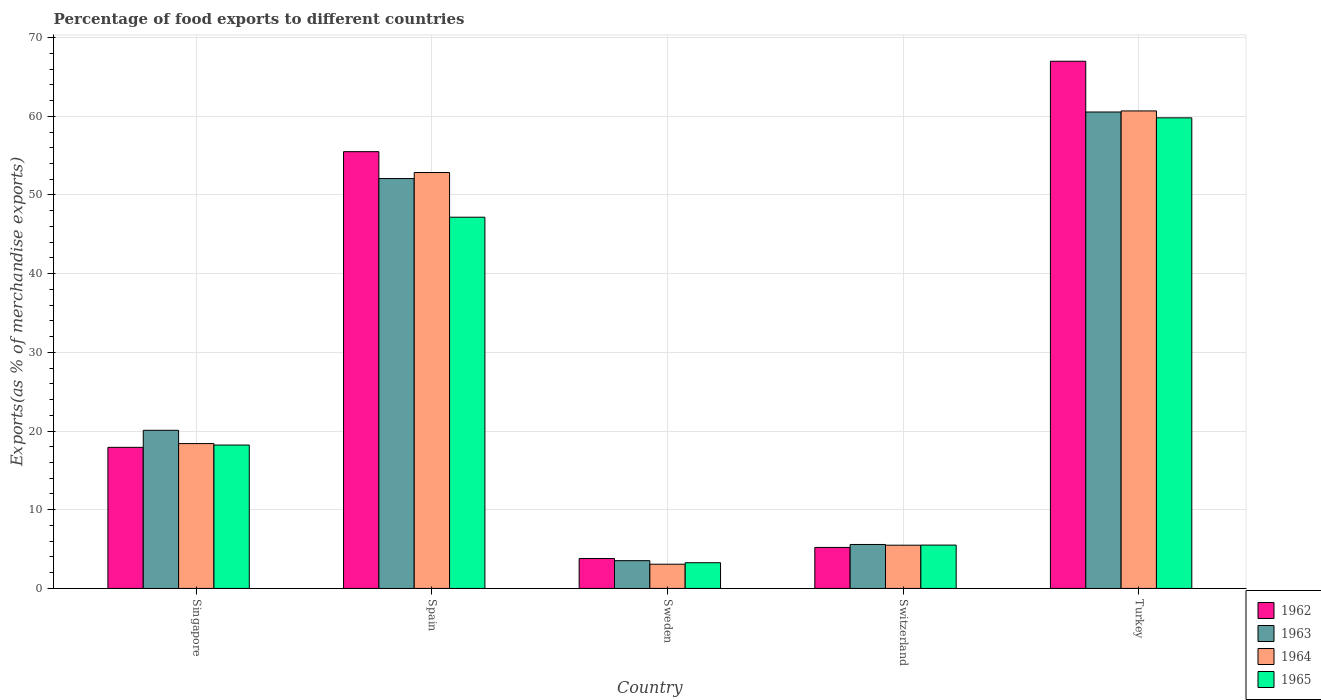How many different coloured bars are there?
Your answer should be compact. 4. Are the number of bars on each tick of the X-axis equal?
Provide a short and direct response. Yes. How many bars are there on the 1st tick from the right?
Give a very brief answer. 4. What is the label of the 4th group of bars from the left?
Give a very brief answer. Switzerland. In how many cases, is the number of bars for a given country not equal to the number of legend labels?
Your answer should be very brief. 0. What is the percentage of exports to different countries in 1965 in Singapore?
Provide a succinct answer. 18.22. Across all countries, what is the maximum percentage of exports to different countries in 1965?
Provide a short and direct response. 59.8. Across all countries, what is the minimum percentage of exports to different countries in 1962?
Provide a short and direct response. 3.8. What is the total percentage of exports to different countries in 1962 in the graph?
Ensure brevity in your answer.  149.44. What is the difference between the percentage of exports to different countries in 1963 in Spain and that in Switzerland?
Your answer should be very brief. 46.5. What is the difference between the percentage of exports to different countries in 1965 in Switzerland and the percentage of exports to different countries in 1962 in Spain?
Give a very brief answer. -49.99. What is the average percentage of exports to different countries in 1965 per country?
Make the answer very short. 26.79. What is the difference between the percentage of exports to different countries of/in 1963 and percentage of exports to different countries of/in 1962 in Singapore?
Ensure brevity in your answer.  2.16. What is the ratio of the percentage of exports to different countries in 1962 in Spain to that in Switzerland?
Your answer should be compact. 10.65. Is the percentage of exports to different countries in 1963 in Spain less than that in Switzerland?
Offer a terse response. No. Is the difference between the percentage of exports to different countries in 1963 in Spain and Sweden greater than the difference between the percentage of exports to different countries in 1962 in Spain and Sweden?
Provide a short and direct response. No. What is the difference between the highest and the second highest percentage of exports to different countries in 1963?
Offer a terse response. 40.45. What is the difference between the highest and the lowest percentage of exports to different countries in 1962?
Provide a short and direct response. 63.19. Is the sum of the percentage of exports to different countries in 1964 in Sweden and Switzerland greater than the maximum percentage of exports to different countries in 1963 across all countries?
Keep it short and to the point. No. What does the 2nd bar from the right in Switzerland represents?
Provide a short and direct response. 1964. Are all the bars in the graph horizontal?
Give a very brief answer. No. How many countries are there in the graph?
Give a very brief answer. 5. Are the values on the major ticks of Y-axis written in scientific E-notation?
Keep it short and to the point. No. Does the graph contain any zero values?
Offer a terse response. No. Does the graph contain grids?
Give a very brief answer. Yes. Where does the legend appear in the graph?
Give a very brief answer. Bottom right. How many legend labels are there?
Make the answer very short. 4. What is the title of the graph?
Make the answer very short. Percentage of food exports to different countries. What is the label or title of the Y-axis?
Keep it short and to the point. Exports(as % of merchandise exports). What is the Exports(as % of merchandise exports) in 1962 in Singapore?
Provide a short and direct response. 17.93. What is the Exports(as % of merchandise exports) in 1963 in Singapore?
Ensure brevity in your answer.  20.09. What is the Exports(as % of merchandise exports) of 1964 in Singapore?
Ensure brevity in your answer.  18.41. What is the Exports(as % of merchandise exports) of 1965 in Singapore?
Keep it short and to the point. 18.22. What is the Exports(as % of merchandise exports) in 1962 in Spain?
Ensure brevity in your answer.  55.5. What is the Exports(as % of merchandise exports) of 1963 in Spain?
Provide a short and direct response. 52.09. What is the Exports(as % of merchandise exports) of 1964 in Spain?
Give a very brief answer. 52.85. What is the Exports(as % of merchandise exports) in 1965 in Spain?
Your answer should be compact. 47.17. What is the Exports(as % of merchandise exports) of 1962 in Sweden?
Ensure brevity in your answer.  3.8. What is the Exports(as % of merchandise exports) in 1963 in Sweden?
Provide a short and direct response. 3.53. What is the Exports(as % of merchandise exports) in 1964 in Sweden?
Provide a succinct answer. 3.08. What is the Exports(as % of merchandise exports) of 1965 in Sweden?
Keep it short and to the point. 3.27. What is the Exports(as % of merchandise exports) of 1962 in Switzerland?
Make the answer very short. 5.21. What is the Exports(as % of merchandise exports) in 1963 in Switzerland?
Provide a succinct answer. 5.59. What is the Exports(as % of merchandise exports) in 1964 in Switzerland?
Make the answer very short. 5.49. What is the Exports(as % of merchandise exports) in 1965 in Switzerland?
Provide a succinct answer. 5.51. What is the Exports(as % of merchandise exports) in 1962 in Turkey?
Offer a terse response. 66.99. What is the Exports(as % of merchandise exports) of 1963 in Turkey?
Your response must be concise. 60.54. What is the Exports(as % of merchandise exports) in 1964 in Turkey?
Provide a succinct answer. 60.68. What is the Exports(as % of merchandise exports) in 1965 in Turkey?
Give a very brief answer. 59.8. Across all countries, what is the maximum Exports(as % of merchandise exports) of 1962?
Your response must be concise. 66.99. Across all countries, what is the maximum Exports(as % of merchandise exports) of 1963?
Keep it short and to the point. 60.54. Across all countries, what is the maximum Exports(as % of merchandise exports) of 1964?
Your answer should be compact. 60.68. Across all countries, what is the maximum Exports(as % of merchandise exports) of 1965?
Provide a succinct answer. 59.8. Across all countries, what is the minimum Exports(as % of merchandise exports) of 1962?
Keep it short and to the point. 3.8. Across all countries, what is the minimum Exports(as % of merchandise exports) in 1963?
Offer a very short reply. 3.53. Across all countries, what is the minimum Exports(as % of merchandise exports) of 1964?
Give a very brief answer. 3.08. Across all countries, what is the minimum Exports(as % of merchandise exports) in 1965?
Provide a short and direct response. 3.27. What is the total Exports(as % of merchandise exports) in 1962 in the graph?
Make the answer very short. 149.44. What is the total Exports(as % of merchandise exports) in 1963 in the graph?
Provide a succinct answer. 141.83. What is the total Exports(as % of merchandise exports) in 1964 in the graph?
Offer a very short reply. 140.51. What is the total Exports(as % of merchandise exports) of 1965 in the graph?
Provide a succinct answer. 133.97. What is the difference between the Exports(as % of merchandise exports) of 1962 in Singapore and that in Spain?
Your response must be concise. -37.57. What is the difference between the Exports(as % of merchandise exports) in 1963 in Singapore and that in Spain?
Make the answer very short. -31.99. What is the difference between the Exports(as % of merchandise exports) in 1964 in Singapore and that in Spain?
Keep it short and to the point. -34.45. What is the difference between the Exports(as % of merchandise exports) in 1965 in Singapore and that in Spain?
Your answer should be very brief. -28.95. What is the difference between the Exports(as % of merchandise exports) of 1962 in Singapore and that in Sweden?
Keep it short and to the point. 14.13. What is the difference between the Exports(as % of merchandise exports) in 1963 in Singapore and that in Sweden?
Your answer should be compact. 16.56. What is the difference between the Exports(as % of merchandise exports) of 1964 in Singapore and that in Sweden?
Offer a very short reply. 15.33. What is the difference between the Exports(as % of merchandise exports) in 1965 in Singapore and that in Sweden?
Your response must be concise. 14.95. What is the difference between the Exports(as % of merchandise exports) in 1962 in Singapore and that in Switzerland?
Keep it short and to the point. 12.72. What is the difference between the Exports(as % of merchandise exports) in 1963 in Singapore and that in Switzerland?
Make the answer very short. 14.51. What is the difference between the Exports(as % of merchandise exports) in 1964 in Singapore and that in Switzerland?
Ensure brevity in your answer.  12.91. What is the difference between the Exports(as % of merchandise exports) of 1965 in Singapore and that in Switzerland?
Ensure brevity in your answer.  12.71. What is the difference between the Exports(as % of merchandise exports) of 1962 in Singapore and that in Turkey?
Provide a short and direct response. -49.06. What is the difference between the Exports(as % of merchandise exports) of 1963 in Singapore and that in Turkey?
Your answer should be compact. -40.45. What is the difference between the Exports(as % of merchandise exports) in 1964 in Singapore and that in Turkey?
Your answer should be very brief. -42.27. What is the difference between the Exports(as % of merchandise exports) in 1965 in Singapore and that in Turkey?
Offer a terse response. -41.58. What is the difference between the Exports(as % of merchandise exports) of 1962 in Spain and that in Sweden?
Provide a succinct answer. 51.7. What is the difference between the Exports(as % of merchandise exports) in 1963 in Spain and that in Sweden?
Offer a very short reply. 48.56. What is the difference between the Exports(as % of merchandise exports) of 1964 in Spain and that in Sweden?
Ensure brevity in your answer.  49.77. What is the difference between the Exports(as % of merchandise exports) in 1965 in Spain and that in Sweden?
Give a very brief answer. 43.9. What is the difference between the Exports(as % of merchandise exports) in 1962 in Spain and that in Switzerland?
Offer a very short reply. 50.29. What is the difference between the Exports(as % of merchandise exports) in 1963 in Spain and that in Switzerland?
Ensure brevity in your answer.  46.5. What is the difference between the Exports(as % of merchandise exports) of 1964 in Spain and that in Switzerland?
Offer a terse response. 47.36. What is the difference between the Exports(as % of merchandise exports) in 1965 in Spain and that in Switzerland?
Keep it short and to the point. 41.67. What is the difference between the Exports(as % of merchandise exports) in 1962 in Spain and that in Turkey?
Your response must be concise. -11.49. What is the difference between the Exports(as % of merchandise exports) in 1963 in Spain and that in Turkey?
Offer a very short reply. -8.46. What is the difference between the Exports(as % of merchandise exports) of 1964 in Spain and that in Turkey?
Provide a short and direct response. -7.83. What is the difference between the Exports(as % of merchandise exports) in 1965 in Spain and that in Turkey?
Your response must be concise. -12.63. What is the difference between the Exports(as % of merchandise exports) in 1962 in Sweden and that in Switzerland?
Provide a short and direct response. -1.4. What is the difference between the Exports(as % of merchandise exports) of 1963 in Sweden and that in Switzerland?
Give a very brief answer. -2.06. What is the difference between the Exports(as % of merchandise exports) in 1964 in Sweden and that in Switzerland?
Ensure brevity in your answer.  -2.41. What is the difference between the Exports(as % of merchandise exports) in 1965 in Sweden and that in Switzerland?
Offer a terse response. -2.24. What is the difference between the Exports(as % of merchandise exports) in 1962 in Sweden and that in Turkey?
Your response must be concise. -63.19. What is the difference between the Exports(as % of merchandise exports) of 1963 in Sweden and that in Turkey?
Your response must be concise. -57.01. What is the difference between the Exports(as % of merchandise exports) of 1964 in Sweden and that in Turkey?
Provide a short and direct response. -57.6. What is the difference between the Exports(as % of merchandise exports) of 1965 in Sweden and that in Turkey?
Provide a succinct answer. -56.53. What is the difference between the Exports(as % of merchandise exports) in 1962 in Switzerland and that in Turkey?
Ensure brevity in your answer.  -61.78. What is the difference between the Exports(as % of merchandise exports) of 1963 in Switzerland and that in Turkey?
Offer a terse response. -54.96. What is the difference between the Exports(as % of merchandise exports) in 1964 in Switzerland and that in Turkey?
Keep it short and to the point. -55.18. What is the difference between the Exports(as % of merchandise exports) of 1965 in Switzerland and that in Turkey?
Give a very brief answer. -54.29. What is the difference between the Exports(as % of merchandise exports) of 1962 in Singapore and the Exports(as % of merchandise exports) of 1963 in Spain?
Keep it short and to the point. -34.16. What is the difference between the Exports(as % of merchandise exports) of 1962 in Singapore and the Exports(as % of merchandise exports) of 1964 in Spain?
Offer a very short reply. -34.92. What is the difference between the Exports(as % of merchandise exports) of 1962 in Singapore and the Exports(as % of merchandise exports) of 1965 in Spain?
Make the answer very short. -29.24. What is the difference between the Exports(as % of merchandise exports) in 1963 in Singapore and the Exports(as % of merchandise exports) in 1964 in Spain?
Your response must be concise. -32.76. What is the difference between the Exports(as % of merchandise exports) in 1963 in Singapore and the Exports(as % of merchandise exports) in 1965 in Spain?
Your answer should be compact. -27.08. What is the difference between the Exports(as % of merchandise exports) in 1964 in Singapore and the Exports(as % of merchandise exports) in 1965 in Spain?
Keep it short and to the point. -28.77. What is the difference between the Exports(as % of merchandise exports) of 1962 in Singapore and the Exports(as % of merchandise exports) of 1963 in Sweden?
Offer a very short reply. 14.4. What is the difference between the Exports(as % of merchandise exports) in 1962 in Singapore and the Exports(as % of merchandise exports) in 1964 in Sweden?
Give a very brief answer. 14.85. What is the difference between the Exports(as % of merchandise exports) of 1962 in Singapore and the Exports(as % of merchandise exports) of 1965 in Sweden?
Give a very brief answer. 14.66. What is the difference between the Exports(as % of merchandise exports) of 1963 in Singapore and the Exports(as % of merchandise exports) of 1964 in Sweden?
Ensure brevity in your answer.  17.01. What is the difference between the Exports(as % of merchandise exports) of 1963 in Singapore and the Exports(as % of merchandise exports) of 1965 in Sweden?
Make the answer very short. 16.83. What is the difference between the Exports(as % of merchandise exports) in 1964 in Singapore and the Exports(as % of merchandise exports) in 1965 in Sweden?
Provide a succinct answer. 15.14. What is the difference between the Exports(as % of merchandise exports) of 1962 in Singapore and the Exports(as % of merchandise exports) of 1963 in Switzerland?
Keep it short and to the point. 12.34. What is the difference between the Exports(as % of merchandise exports) in 1962 in Singapore and the Exports(as % of merchandise exports) in 1964 in Switzerland?
Your answer should be compact. 12.44. What is the difference between the Exports(as % of merchandise exports) of 1962 in Singapore and the Exports(as % of merchandise exports) of 1965 in Switzerland?
Make the answer very short. 12.42. What is the difference between the Exports(as % of merchandise exports) of 1963 in Singapore and the Exports(as % of merchandise exports) of 1964 in Switzerland?
Offer a very short reply. 14.6. What is the difference between the Exports(as % of merchandise exports) in 1963 in Singapore and the Exports(as % of merchandise exports) in 1965 in Switzerland?
Your response must be concise. 14.59. What is the difference between the Exports(as % of merchandise exports) in 1964 in Singapore and the Exports(as % of merchandise exports) in 1965 in Switzerland?
Ensure brevity in your answer.  12.9. What is the difference between the Exports(as % of merchandise exports) in 1962 in Singapore and the Exports(as % of merchandise exports) in 1963 in Turkey?
Your answer should be compact. -42.61. What is the difference between the Exports(as % of merchandise exports) in 1962 in Singapore and the Exports(as % of merchandise exports) in 1964 in Turkey?
Your answer should be compact. -42.75. What is the difference between the Exports(as % of merchandise exports) in 1962 in Singapore and the Exports(as % of merchandise exports) in 1965 in Turkey?
Provide a succinct answer. -41.87. What is the difference between the Exports(as % of merchandise exports) in 1963 in Singapore and the Exports(as % of merchandise exports) in 1964 in Turkey?
Offer a terse response. -40.59. What is the difference between the Exports(as % of merchandise exports) in 1963 in Singapore and the Exports(as % of merchandise exports) in 1965 in Turkey?
Offer a very short reply. -39.71. What is the difference between the Exports(as % of merchandise exports) in 1964 in Singapore and the Exports(as % of merchandise exports) in 1965 in Turkey?
Give a very brief answer. -41.39. What is the difference between the Exports(as % of merchandise exports) in 1962 in Spain and the Exports(as % of merchandise exports) in 1963 in Sweden?
Offer a very short reply. 51.97. What is the difference between the Exports(as % of merchandise exports) in 1962 in Spain and the Exports(as % of merchandise exports) in 1964 in Sweden?
Keep it short and to the point. 52.42. What is the difference between the Exports(as % of merchandise exports) in 1962 in Spain and the Exports(as % of merchandise exports) in 1965 in Sweden?
Your response must be concise. 52.23. What is the difference between the Exports(as % of merchandise exports) of 1963 in Spain and the Exports(as % of merchandise exports) of 1964 in Sweden?
Make the answer very short. 49.01. What is the difference between the Exports(as % of merchandise exports) of 1963 in Spain and the Exports(as % of merchandise exports) of 1965 in Sweden?
Your response must be concise. 48.82. What is the difference between the Exports(as % of merchandise exports) in 1964 in Spain and the Exports(as % of merchandise exports) in 1965 in Sweden?
Give a very brief answer. 49.58. What is the difference between the Exports(as % of merchandise exports) of 1962 in Spain and the Exports(as % of merchandise exports) of 1963 in Switzerland?
Ensure brevity in your answer.  49.92. What is the difference between the Exports(as % of merchandise exports) of 1962 in Spain and the Exports(as % of merchandise exports) of 1964 in Switzerland?
Provide a short and direct response. 50.01. What is the difference between the Exports(as % of merchandise exports) of 1962 in Spain and the Exports(as % of merchandise exports) of 1965 in Switzerland?
Give a very brief answer. 49.99. What is the difference between the Exports(as % of merchandise exports) in 1963 in Spain and the Exports(as % of merchandise exports) in 1964 in Switzerland?
Your answer should be very brief. 46.59. What is the difference between the Exports(as % of merchandise exports) in 1963 in Spain and the Exports(as % of merchandise exports) in 1965 in Switzerland?
Your response must be concise. 46.58. What is the difference between the Exports(as % of merchandise exports) in 1964 in Spain and the Exports(as % of merchandise exports) in 1965 in Switzerland?
Your response must be concise. 47.35. What is the difference between the Exports(as % of merchandise exports) in 1962 in Spain and the Exports(as % of merchandise exports) in 1963 in Turkey?
Offer a terse response. -5.04. What is the difference between the Exports(as % of merchandise exports) in 1962 in Spain and the Exports(as % of merchandise exports) in 1964 in Turkey?
Offer a very short reply. -5.18. What is the difference between the Exports(as % of merchandise exports) of 1962 in Spain and the Exports(as % of merchandise exports) of 1965 in Turkey?
Your response must be concise. -4.3. What is the difference between the Exports(as % of merchandise exports) of 1963 in Spain and the Exports(as % of merchandise exports) of 1964 in Turkey?
Your answer should be very brief. -8.59. What is the difference between the Exports(as % of merchandise exports) in 1963 in Spain and the Exports(as % of merchandise exports) in 1965 in Turkey?
Provide a succinct answer. -7.71. What is the difference between the Exports(as % of merchandise exports) in 1964 in Spain and the Exports(as % of merchandise exports) in 1965 in Turkey?
Give a very brief answer. -6.95. What is the difference between the Exports(as % of merchandise exports) of 1962 in Sweden and the Exports(as % of merchandise exports) of 1963 in Switzerland?
Ensure brevity in your answer.  -1.78. What is the difference between the Exports(as % of merchandise exports) in 1962 in Sweden and the Exports(as % of merchandise exports) in 1964 in Switzerland?
Offer a very short reply. -1.69. What is the difference between the Exports(as % of merchandise exports) in 1962 in Sweden and the Exports(as % of merchandise exports) in 1965 in Switzerland?
Your answer should be very brief. -1.7. What is the difference between the Exports(as % of merchandise exports) in 1963 in Sweden and the Exports(as % of merchandise exports) in 1964 in Switzerland?
Give a very brief answer. -1.96. What is the difference between the Exports(as % of merchandise exports) of 1963 in Sweden and the Exports(as % of merchandise exports) of 1965 in Switzerland?
Offer a very short reply. -1.98. What is the difference between the Exports(as % of merchandise exports) in 1964 in Sweden and the Exports(as % of merchandise exports) in 1965 in Switzerland?
Offer a very short reply. -2.43. What is the difference between the Exports(as % of merchandise exports) of 1962 in Sweden and the Exports(as % of merchandise exports) of 1963 in Turkey?
Your answer should be compact. -56.74. What is the difference between the Exports(as % of merchandise exports) in 1962 in Sweden and the Exports(as % of merchandise exports) in 1964 in Turkey?
Offer a very short reply. -56.87. What is the difference between the Exports(as % of merchandise exports) of 1962 in Sweden and the Exports(as % of merchandise exports) of 1965 in Turkey?
Give a very brief answer. -55.99. What is the difference between the Exports(as % of merchandise exports) in 1963 in Sweden and the Exports(as % of merchandise exports) in 1964 in Turkey?
Provide a succinct answer. -57.15. What is the difference between the Exports(as % of merchandise exports) in 1963 in Sweden and the Exports(as % of merchandise exports) in 1965 in Turkey?
Offer a very short reply. -56.27. What is the difference between the Exports(as % of merchandise exports) of 1964 in Sweden and the Exports(as % of merchandise exports) of 1965 in Turkey?
Provide a succinct answer. -56.72. What is the difference between the Exports(as % of merchandise exports) of 1962 in Switzerland and the Exports(as % of merchandise exports) of 1963 in Turkey?
Offer a very short reply. -55.33. What is the difference between the Exports(as % of merchandise exports) in 1962 in Switzerland and the Exports(as % of merchandise exports) in 1964 in Turkey?
Make the answer very short. -55.47. What is the difference between the Exports(as % of merchandise exports) in 1962 in Switzerland and the Exports(as % of merchandise exports) in 1965 in Turkey?
Ensure brevity in your answer.  -54.59. What is the difference between the Exports(as % of merchandise exports) of 1963 in Switzerland and the Exports(as % of merchandise exports) of 1964 in Turkey?
Give a very brief answer. -55.09. What is the difference between the Exports(as % of merchandise exports) in 1963 in Switzerland and the Exports(as % of merchandise exports) in 1965 in Turkey?
Give a very brief answer. -54.21. What is the difference between the Exports(as % of merchandise exports) of 1964 in Switzerland and the Exports(as % of merchandise exports) of 1965 in Turkey?
Keep it short and to the point. -54.31. What is the average Exports(as % of merchandise exports) in 1962 per country?
Provide a short and direct response. 29.89. What is the average Exports(as % of merchandise exports) in 1963 per country?
Provide a short and direct response. 28.37. What is the average Exports(as % of merchandise exports) of 1964 per country?
Your answer should be compact. 28.1. What is the average Exports(as % of merchandise exports) in 1965 per country?
Your answer should be compact. 26.79. What is the difference between the Exports(as % of merchandise exports) in 1962 and Exports(as % of merchandise exports) in 1963 in Singapore?
Make the answer very short. -2.16. What is the difference between the Exports(as % of merchandise exports) of 1962 and Exports(as % of merchandise exports) of 1964 in Singapore?
Give a very brief answer. -0.48. What is the difference between the Exports(as % of merchandise exports) in 1962 and Exports(as % of merchandise exports) in 1965 in Singapore?
Keep it short and to the point. -0.29. What is the difference between the Exports(as % of merchandise exports) of 1963 and Exports(as % of merchandise exports) of 1964 in Singapore?
Make the answer very short. 1.69. What is the difference between the Exports(as % of merchandise exports) in 1963 and Exports(as % of merchandise exports) in 1965 in Singapore?
Give a very brief answer. 1.87. What is the difference between the Exports(as % of merchandise exports) in 1964 and Exports(as % of merchandise exports) in 1965 in Singapore?
Your answer should be compact. 0.18. What is the difference between the Exports(as % of merchandise exports) in 1962 and Exports(as % of merchandise exports) in 1963 in Spain?
Ensure brevity in your answer.  3.42. What is the difference between the Exports(as % of merchandise exports) of 1962 and Exports(as % of merchandise exports) of 1964 in Spain?
Make the answer very short. 2.65. What is the difference between the Exports(as % of merchandise exports) of 1962 and Exports(as % of merchandise exports) of 1965 in Spain?
Your response must be concise. 8.33. What is the difference between the Exports(as % of merchandise exports) in 1963 and Exports(as % of merchandise exports) in 1964 in Spain?
Your answer should be compact. -0.77. What is the difference between the Exports(as % of merchandise exports) of 1963 and Exports(as % of merchandise exports) of 1965 in Spain?
Offer a terse response. 4.91. What is the difference between the Exports(as % of merchandise exports) in 1964 and Exports(as % of merchandise exports) in 1965 in Spain?
Offer a very short reply. 5.68. What is the difference between the Exports(as % of merchandise exports) in 1962 and Exports(as % of merchandise exports) in 1963 in Sweden?
Offer a terse response. 0.28. What is the difference between the Exports(as % of merchandise exports) in 1962 and Exports(as % of merchandise exports) in 1964 in Sweden?
Make the answer very short. 0.73. What is the difference between the Exports(as % of merchandise exports) of 1962 and Exports(as % of merchandise exports) of 1965 in Sweden?
Provide a short and direct response. 0.54. What is the difference between the Exports(as % of merchandise exports) in 1963 and Exports(as % of merchandise exports) in 1964 in Sweden?
Offer a very short reply. 0.45. What is the difference between the Exports(as % of merchandise exports) of 1963 and Exports(as % of merchandise exports) of 1965 in Sweden?
Offer a very short reply. 0.26. What is the difference between the Exports(as % of merchandise exports) in 1964 and Exports(as % of merchandise exports) in 1965 in Sweden?
Give a very brief answer. -0.19. What is the difference between the Exports(as % of merchandise exports) of 1962 and Exports(as % of merchandise exports) of 1963 in Switzerland?
Make the answer very short. -0.38. What is the difference between the Exports(as % of merchandise exports) in 1962 and Exports(as % of merchandise exports) in 1964 in Switzerland?
Ensure brevity in your answer.  -0.28. What is the difference between the Exports(as % of merchandise exports) of 1962 and Exports(as % of merchandise exports) of 1965 in Switzerland?
Your answer should be compact. -0.3. What is the difference between the Exports(as % of merchandise exports) in 1963 and Exports(as % of merchandise exports) in 1964 in Switzerland?
Your response must be concise. 0.09. What is the difference between the Exports(as % of merchandise exports) in 1963 and Exports(as % of merchandise exports) in 1965 in Switzerland?
Offer a very short reply. 0.08. What is the difference between the Exports(as % of merchandise exports) of 1964 and Exports(as % of merchandise exports) of 1965 in Switzerland?
Offer a very short reply. -0.01. What is the difference between the Exports(as % of merchandise exports) of 1962 and Exports(as % of merchandise exports) of 1963 in Turkey?
Offer a terse response. 6.45. What is the difference between the Exports(as % of merchandise exports) of 1962 and Exports(as % of merchandise exports) of 1964 in Turkey?
Make the answer very short. 6.31. What is the difference between the Exports(as % of merchandise exports) of 1962 and Exports(as % of merchandise exports) of 1965 in Turkey?
Offer a terse response. 7.19. What is the difference between the Exports(as % of merchandise exports) in 1963 and Exports(as % of merchandise exports) in 1964 in Turkey?
Keep it short and to the point. -0.14. What is the difference between the Exports(as % of merchandise exports) in 1963 and Exports(as % of merchandise exports) in 1965 in Turkey?
Keep it short and to the point. 0.74. What is the difference between the Exports(as % of merchandise exports) in 1964 and Exports(as % of merchandise exports) in 1965 in Turkey?
Ensure brevity in your answer.  0.88. What is the ratio of the Exports(as % of merchandise exports) of 1962 in Singapore to that in Spain?
Provide a short and direct response. 0.32. What is the ratio of the Exports(as % of merchandise exports) of 1963 in Singapore to that in Spain?
Your response must be concise. 0.39. What is the ratio of the Exports(as % of merchandise exports) of 1964 in Singapore to that in Spain?
Your answer should be very brief. 0.35. What is the ratio of the Exports(as % of merchandise exports) of 1965 in Singapore to that in Spain?
Provide a succinct answer. 0.39. What is the ratio of the Exports(as % of merchandise exports) in 1962 in Singapore to that in Sweden?
Keep it short and to the point. 4.71. What is the ratio of the Exports(as % of merchandise exports) in 1963 in Singapore to that in Sweden?
Provide a succinct answer. 5.69. What is the ratio of the Exports(as % of merchandise exports) in 1964 in Singapore to that in Sweden?
Keep it short and to the point. 5.98. What is the ratio of the Exports(as % of merchandise exports) in 1965 in Singapore to that in Sweden?
Your answer should be very brief. 5.58. What is the ratio of the Exports(as % of merchandise exports) in 1962 in Singapore to that in Switzerland?
Provide a short and direct response. 3.44. What is the ratio of the Exports(as % of merchandise exports) of 1963 in Singapore to that in Switzerland?
Your answer should be compact. 3.6. What is the ratio of the Exports(as % of merchandise exports) in 1964 in Singapore to that in Switzerland?
Provide a short and direct response. 3.35. What is the ratio of the Exports(as % of merchandise exports) in 1965 in Singapore to that in Switzerland?
Make the answer very short. 3.31. What is the ratio of the Exports(as % of merchandise exports) in 1962 in Singapore to that in Turkey?
Provide a succinct answer. 0.27. What is the ratio of the Exports(as % of merchandise exports) of 1963 in Singapore to that in Turkey?
Offer a terse response. 0.33. What is the ratio of the Exports(as % of merchandise exports) in 1964 in Singapore to that in Turkey?
Your answer should be very brief. 0.3. What is the ratio of the Exports(as % of merchandise exports) in 1965 in Singapore to that in Turkey?
Offer a very short reply. 0.3. What is the ratio of the Exports(as % of merchandise exports) in 1962 in Spain to that in Sweden?
Keep it short and to the point. 14.59. What is the ratio of the Exports(as % of merchandise exports) of 1963 in Spain to that in Sweden?
Offer a very short reply. 14.76. What is the ratio of the Exports(as % of merchandise exports) of 1964 in Spain to that in Sweden?
Offer a terse response. 17.17. What is the ratio of the Exports(as % of merchandise exports) of 1965 in Spain to that in Sweden?
Give a very brief answer. 14.44. What is the ratio of the Exports(as % of merchandise exports) of 1962 in Spain to that in Switzerland?
Provide a short and direct response. 10.65. What is the ratio of the Exports(as % of merchandise exports) of 1963 in Spain to that in Switzerland?
Offer a terse response. 9.33. What is the ratio of the Exports(as % of merchandise exports) of 1964 in Spain to that in Switzerland?
Offer a terse response. 9.62. What is the ratio of the Exports(as % of merchandise exports) in 1965 in Spain to that in Switzerland?
Give a very brief answer. 8.57. What is the ratio of the Exports(as % of merchandise exports) in 1962 in Spain to that in Turkey?
Offer a terse response. 0.83. What is the ratio of the Exports(as % of merchandise exports) in 1963 in Spain to that in Turkey?
Your answer should be very brief. 0.86. What is the ratio of the Exports(as % of merchandise exports) in 1964 in Spain to that in Turkey?
Your answer should be very brief. 0.87. What is the ratio of the Exports(as % of merchandise exports) of 1965 in Spain to that in Turkey?
Ensure brevity in your answer.  0.79. What is the ratio of the Exports(as % of merchandise exports) in 1962 in Sweden to that in Switzerland?
Your answer should be very brief. 0.73. What is the ratio of the Exports(as % of merchandise exports) in 1963 in Sweden to that in Switzerland?
Give a very brief answer. 0.63. What is the ratio of the Exports(as % of merchandise exports) in 1964 in Sweden to that in Switzerland?
Your answer should be very brief. 0.56. What is the ratio of the Exports(as % of merchandise exports) of 1965 in Sweden to that in Switzerland?
Provide a short and direct response. 0.59. What is the ratio of the Exports(as % of merchandise exports) of 1962 in Sweden to that in Turkey?
Give a very brief answer. 0.06. What is the ratio of the Exports(as % of merchandise exports) in 1963 in Sweden to that in Turkey?
Offer a very short reply. 0.06. What is the ratio of the Exports(as % of merchandise exports) in 1964 in Sweden to that in Turkey?
Your answer should be compact. 0.05. What is the ratio of the Exports(as % of merchandise exports) in 1965 in Sweden to that in Turkey?
Your answer should be compact. 0.05. What is the ratio of the Exports(as % of merchandise exports) in 1962 in Switzerland to that in Turkey?
Offer a very short reply. 0.08. What is the ratio of the Exports(as % of merchandise exports) in 1963 in Switzerland to that in Turkey?
Your answer should be very brief. 0.09. What is the ratio of the Exports(as % of merchandise exports) of 1964 in Switzerland to that in Turkey?
Offer a terse response. 0.09. What is the ratio of the Exports(as % of merchandise exports) of 1965 in Switzerland to that in Turkey?
Offer a very short reply. 0.09. What is the difference between the highest and the second highest Exports(as % of merchandise exports) of 1962?
Your answer should be very brief. 11.49. What is the difference between the highest and the second highest Exports(as % of merchandise exports) of 1963?
Give a very brief answer. 8.46. What is the difference between the highest and the second highest Exports(as % of merchandise exports) in 1964?
Offer a terse response. 7.83. What is the difference between the highest and the second highest Exports(as % of merchandise exports) in 1965?
Your response must be concise. 12.63. What is the difference between the highest and the lowest Exports(as % of merchandise exports) of 1962?
Make the answer very short. 63.19. What is the difference between the highest and the lowest Exports(as % of merchandise exports) in 1963?
Offer a very short reply. 57.01. What is the difference between the highest and the lowest Exports(as % of merchandise exports) in 1964?
Your answer should be compact. 57.6. What is the difference between the highest and the lowest Exports(as % of merchandise exports) in 1965?
Offer a very short reply. 56.53. 